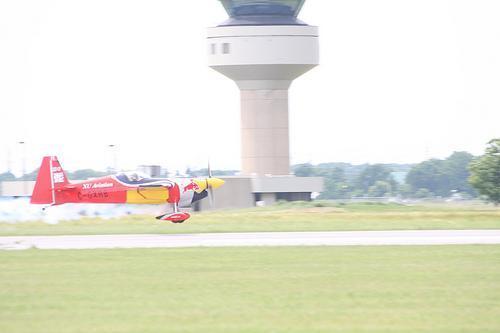How many planes flying?
Give a very brief answer. 1. 